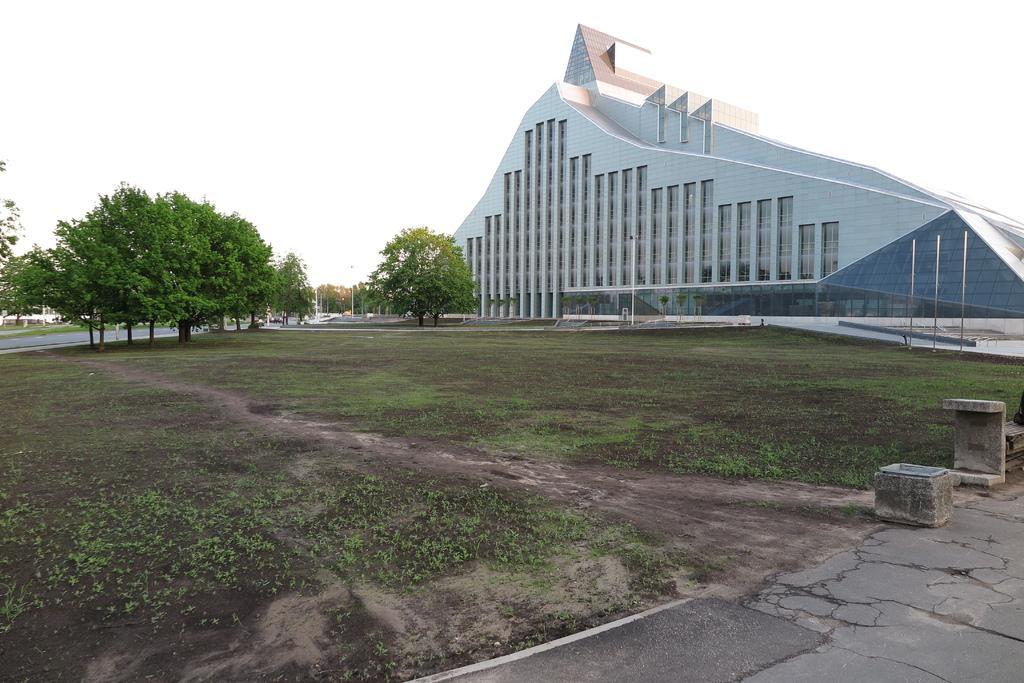In one or two sentences, can you explain what this image depicts? In this image we can see building, trees, sky, ground, floor, pole and fountains. 